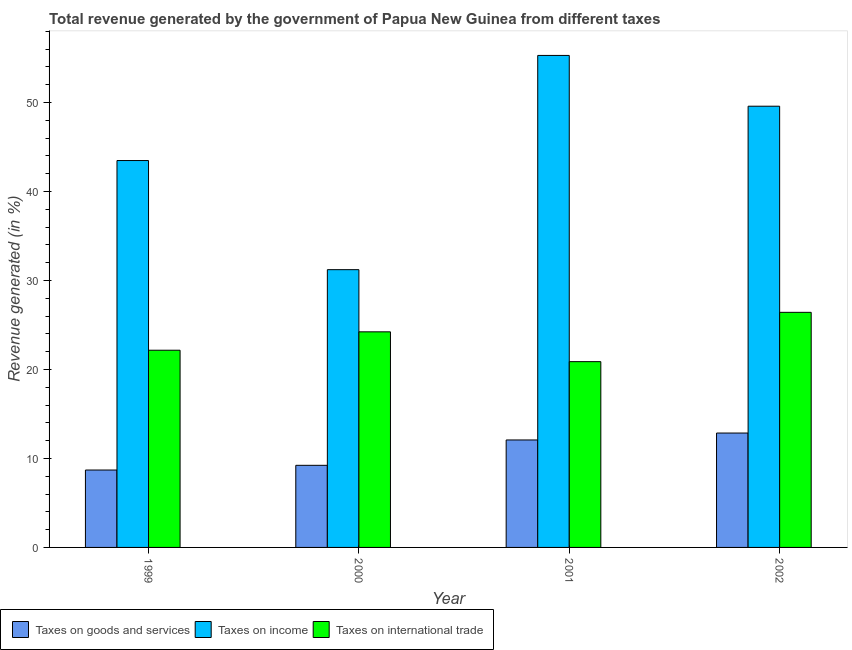Are the number of bars per tick equal to the number of legend labels?
Your answer should be compact. Yes. Are the number of bars on each tick of the X-axis equal?
Ensure brevity in your answer.  Yes. How many bars are there on the 4th tick from the left?
Your answer should be compact. 3. How many bars are there on the 1st tick from the right?
Provide a short and direct response. 3. What is the label of the 2nd group of bars from the left?
Offer a terse response. 2000. What is the percentage of revenue generated by taxes on goods and services in 2001?
Keep it short and to the point. 12.08. Across all years, what is the maximum percentage of revenue generated by taxes on goods and services?
Your answer should be compact. 12.86. Across all years, what is the minimum percentage of revenue generated by taxes on goods and services?
Offer a very short reply. 8.7. In which year was the percentage of revenue generated by tax on international trade maximum?
Your response must be concise. 2002. What is the total percentage of revenue generated by tax on international trade in the graph?
Offer a terse response. 93.7. What is the difference between the percentage of revenue generated by taxes on goods and services in 2001 and that in 2002?
Keep it short and to the point. -0.78. What is the difference between the percentage of revenue generated by taxes on goods and services in 1999 and the percentage of revenue generated by taxes on income in 2001?
Offer a terse response. -3.38. What is the average percentage of revenue generated by taxes on income per year?
Offer a very short reply. 44.9. What is the ratio of the percentage of revenue generated by tax on international trade in 1999 to that in 2000?
Your answer should be very brief. 0.91. Is the difference between the percentage of revenue generated by tax on international trade in 2000 and 2002 greater than the difference between the percentage of revenue generated by taxes on goods and services in 2000 and 2002?
Offer a very short reply. No. What is the difference between the highest and the second highest percentage of revenue generated by taxes on income?
Provide a succinct answer. 5.71. What is the difference between the highest and the lowest percentage of revenue generated by tax on international trade?
Your answer should be compact. 5.54. What does the 2nd bar from the left in 2002 represents?
Ensure brevity in your answer.  Taxes on income. What does the 1st bar from the right in 2002 represents?
Keep it short and to the point. Taxes on international trade. Is it the case that in every year, the sum of the percentage of revenue generated by taxes on goods and services and percentage of revenue generated by taxes on income is greater than the percentage of revenue generated by tax on international trade?
Offer a very short reply. Yes. Are the values on the major ticks of Y-axis written in scientific E-notation?
Offer a very short reply. No. Where does the legend appear in the graph?
Provide a short and direct response. Bottom left. What is the title of the graph?
Give a very brief answer. Total revenue generated by the government of Papua New Guinea from different taxes. What is the label or title of the X-axis?
Provide a short and direct response. Year. What is the label or title of the Y-axis?
Give a very brief answer. Revenue generated (in %). What is the Revenue generated (in %) in Taxes on goods and services in 1999?
Your response must be concise. 8.7. What is the Revenue generated (in %) in Taxes on income in 1999?
Your answer should be very brief. 43.48. What is the Revenue generated (in %) in Taxes on international trade in 1999?
Provide a short and direct response. 22.16. What is the Revenue generated (in %) in Taxes on goods and services in 2000?
Your answer should be compact. 9.23. What is the Revenue generated (in %) in Taxes on income in 2000?
Give a very brief answer. 31.22. What is the Revenue generated (in %) of Taxes on international trade in 2000?
Keep it short and to the point. 24.23. What is the Revenue generated (in %) in Taxes on goods and services in 2001?
Make the answer very short. 12.08. What is the Revenue generated (in %) in Taxes on income in 2001?
Provide a succinct answer. 55.3. What is the Revenue generated (in %) in Taxes on international trade in 2001?
Provide a succinct answer. 20.88. What is the Revenue generated (in %) of Taxes on goods and services in 2002?
Offer a very short reply. 12.86. What is the Revenue generated (in %) of Taxes on income in 2002?
Your answer should be compact. 49.59. What is the Revenue generated (in %) of Taxes on international trade in 2002?
Ensure brevity in your answer.  26.42. Across all years, what is the maximum Revenue generated (in %) in Taxes on goods and services?
Provide a short and direct response. 12.86. Across all years, what is the maximum Revenue generated (in %) in Taxes on income?
Your response must be concise. 55.3. Across all years, what is the maximum Revenue generated (in %) in Taxes on international trade?
Keep it short and to the point. 26.42. Across all years, what is the minimum Revenue generated (in %) in Taxes on goods and services?
Offer a very short reply. 8.7. Across all years, what is the minimum Revenue generated (in %) in Taxes on income?
Provide a short and direct response. 31.22. Across all years, what is the minimum Revenue generated (in %) in Taxes on international trade?
Provide a short and direct response. 20.88. What is the total Revenue generated (in %) of Taxes on goods and services in the graph?
Provide a succinct answer. 42.86. What is the total Revenue generated (in %) in Taxes on income in the graph?
Offer a terse response. 179.59. What is the total Revenue generated (in %) in Taxes on international trade in the graph?
Give a very brief answer. 93.7. What is the difference between the Revenue generated (in %) in Taxes on goods and services in 1999 and that in 2000?
Your answer should be very brief. -0.53. What is the difference between the Revenue generated (in %) of Taxes on income in 1999 and that in 2000?
Provide a succinct answer. 12.27. What is the difference between the Revenue generated (in %) in Taxes on international trade in 1999 and that in 2000?
Your response must be concise. -2.07. What is the difference between the Revenue generated (in %) of Taxes on goods and services in 1999 and that in 2001?
Make the answer very short. -3.38. What is the difference between the Revenue generated (in %) of Taxes on income in 1999 and that in 2001?
Give a very brief answer. -11.81. What is the difference between the Revenue generated (in %) in Taxes on international trade in 1999 and that in 2001?
Provide a succinct answer. 1.28. What is the difference between the Revenue generated (in %) of Taxes on goods and services in 1999 and that in 2002?
Make the answer very short. -4.16. What is the difference between the Revenue generated (in %) in Taxes on income in 1999 and that in 2002?
Your response must be concise. -6.11. What is the difference between the Revenue generated (in %) in Taxes on international trade in 1999 and that in 2002?
Your answer should be very brief. -4.26. What is the difference between the Revenue generated (in %) in Taxes on goods and services in 2000 and that in 2001?
Offer a terse response. -2.85. What is the difference between the Revenue generated (in %) of Taxes on income in 2000 and that in 2001?
Your response must be concise. -24.08. What is the difference between the Revenue generated (in %) in Taxes on international trade in 2000 and that in 2001?
Give a very brief answer. 3.35. What is the difference between the Revenue generated (in %) in Taxes on goods and services in 2000 and that in 2002?
Provide a short and direct response. -3.63. What is the difference between the Revenue generated (in %) of Taxes on income in 2000 and that in 2002?
Your answer should be very brief. -18.37. What is the difference between the Revenue generated (in %) in Taxes on international trade in 2000 and that in 2002?
Offer a terse response. -2.19. What is the difference between the Revenue generated (in %) in Taxes on goods and services in 2001 and that in 2002?
Ensure brevity in your answer.  -0.78. What is the difference between the Revenue generated (in %) in Taxes on income in 2001 and that in 2002?
Make the answer very short. 5.71. What is the difference between the Revenue generated (in %) in Taxes on international trade in 2001 and that in 2002?
Give a very brief answer. -5.54. What is the difference between the Revenue generated (in %) in Taxes on goods and services in 1999 and the Revenue generated (in %) in Taxes on income in 2000?
Provide a succinct answer. -22.52. What is the difference between the Revenue generated (in %) of Taxes on goods and services in 1999 and the Revenue generated (in %) of Taxes on international trade in 2000?
Your response must be concise. -15.53. What is the difference between the Revenue generated (in %) in Taxes on income in 1999 and the Revenue generated (in %) in Taxes on international trade in 2000?
Provide a short and direct response. 19.25. What is the difference between the Revenue generated (in %) of Taxes on goods and services in 1999 and the Revenue generated (in %) of Taxes on income in 2001?
Ensure brevity in your answer.  -46.6. What is the difference between the Revenue generated (in %) of Taxes on goods and services in 1999 and the Revenue generated (in %) of Taxes on international trade in 2001?
Make the answer very short. -12.18. What is the difference between the Revenue generated (in %) of Taxes on income in 1999 and the Revenue generated (in %) of Taxes on international trade in 2001?
Keep it short and to the point. 22.6. What is the difference between the Revenue generated (in %) in Taxes on goods and services in 1999 and the Revenue generated (in %) in Taxes on income in 2002?
Keep it short and to the point. -40.89. What is the difference between the Revenue generated (in %) of Taxes on goods and services in 1999 and the Revenue generated (in %) of Taxes on international trade in 2002?
Your answer should be compact. -17.72. What is the difference between the Revenue generated (in %) of Taxes on income in 1999 and the Revenue generated (in %) of Taxes on international trade in 2002?
Your answer should be compact. 17.06. What is the difference between the Revenue generated (in %) in Taxes on goods and services in 2000 and the Revenue generated (in %) in Taxes on income in 2001?
Offer a very short reply. -46.07. What is the difference between the Revenue generated (in %) in Taxes on goods and services in 2000 and the Revenue generated (in %) in Taxes on international trade in 2001?
Give a very brief answer. -11.65. What is the difference between the Revenue generated (in %) of Taxes on income in 2000 and the Revenue generated (in %) of Taxes on international trade in 2001?
Provide a succinct answer. 10.34. What is the difference between the Revenue generated (in %) in Taxes on goods and services in 2000 and the Revenue generated (in %) in Taxes on income in 2002?
Your answer should be very brief. -40.36. What is the difference between the Revenue generated (in %) in Taxes on goods and services in 2000 and the Revenue generated (in %) in Taxes on international trade in 2002?
Give a very brief answer. -17.19. What is the difference between the Revenue generated (in %) of Taxes on income in 2000 and the Revenue generated (in %) of Taxes on international trade in 2002?
Keep it short and to the point. 4.79. What is the difference between the Revenue generated (in %) of Taxes on goods and services in 2001 and the Revenue generated (in %) of Taxes on income in 2002?
Your response must be concise. -37.51. What is the difference between the Revenue generated (in %) in Taxes on goods and services in 2001 and the Revenue generated (in %) in Taxes on international trade in 2002?
Ensure brevity in your answer.  -14.35. What is the difference between the Revenue generated (in %) in Taxes on income in 2001 and the Revenue generated (in %) in Taxes on international trade in 2002?
Make the answer very short. 28.87. What is the average Revenue generated (in %) of Taxes on goods and services per year?
Your answer should be very brief. 10.72. What is the average Revenue generated (in %) of Taxes on income per year?
Ensure brevity in your answer.  44.9. What is the average Revenue generated (in %) in Taxes on international trade per year?
Your response must be concise. 23.42. In the year 1999, what is the difference between the Revenue generated (in %) of Taxes on goods and services and Revenue generated (in %) of Taxes on income?
Your answer should be compact. -34.78. In the year 1999, what is the difference between the Revenue generated (in %) of Taxes on goods and services and Revenue generated (in %) of Taxes on international trade?
Ensure brevity in your answer.  -13.46. In the year 1999, what is the difference between the Revenue generated (in %) of Taxes on income and Revenue generated (in %) of Taxes on international trade?
Offer a terse response. 21.32. In the year 2000, what is the difference between the Revenue generated (in %) in Taxes on goods and services and Revenue generated (in %) in Taxes on income?
Provide a succinct answer. -21.99. In the year 2000, what is the difference between the Revenue generated (in %) in Taxes on goods and services and Revenue generated (in %) in Taxes on international trade?
Your answer should be very brief. -15. In the year 2000, what is the difference between the Revenue generated (in %) of Taxes on income and Revenue generated (in %) of Taxes on international trade?
Keep it short and to the point. 6.99. In the year 2001, what is the difference between the Revenue generated (in %) of Taxes on goods and services and Revenue generated (in %) of Taxes on income?
Keep it short and to the point. -43.22. In the year 2001, what is the difference between the Revenue generated (in %) in Taxes on goods and services and Revenue generated (in %) in Taxes on international trade?
Offer a terse response. -8.8. In the year 2001, what is the difference between the Revenue generated (in %) of Taxes on income and Revenue generated (in %) of Taxes on international trade?
Provide a short and direct response. 34.42. In the year 2002, what is the difference between the Revenue generated (in %) in Taxes on goods and services and Revenue generated (in %) in Taxes on income?
Make the answer very short. -36.73. In the year 2002, what is the difference between the Revenue generated (in %) of Taxes on goods and services and Revenue generated (in %) of Taxes on international trade?
Your answer should be very brief. -13.57. In the year 2002, what is the difference between the Revenue generated (in %) of Taxes on income and Revenue generated (in %) of Taxes on international trade?
Give a very brief answer. 23.17. What is the ratio of the Revenue generated (in %) in Taxes on goods and services in 1999 to that in 2000?
Offer a very short reply. 0.94. What is the ratio of the Revenue generated (in %) in Taxes on income in 1999 to that in 2000?
Keep it short and to the point. 1.39. What is the ratio of the Revenue generated (in %) of Taxes on international trade in 1999 to that in 2000?
Make the answer very short. 0.91. What is the ratio of the Revenue generated (in %) in Taxes on goods and services in 1999 to that in 2001?
Give a very brief answer. 0.72. What is the ratio of the Revenue generated (in %) of Taxes on income in 1999 to that in 2001?
Offer a very short reply. 0.79. What is the ratio of the Revenue generated (in %) in Taxes on international trade in 1999 to that in 2001?
Offer a terse response. 1.06. What is the ratio of the Revenue generated (in %) in Taxes on goods and services in 1999 to that in 2002?
Offer a very short reply. 0.68. What is the ratio of the Revenue generated (in %) of Taxes on income in 1999 to that in 2002?
Your response must be concise. 0.88. What is the ratio of the Revenue generated (in %) of Taxes on international trade in 1999 to that in 2002?
Your answer should be compact. 0.84. What is the ratio of the Revenue generated (in %) in Taxes on goods and services in 2000 to that in 2001?
Your answer should be very brief. 0.76. What is the ratio of the Revenue generated (in %) in Taxes on income in 2000 to that in 2001?
Your answer should be compact. 0.56. What is the ratio of the Revenue generated (in %) in Taxes on international trade in 2000 to that in 2001?
Your response must be concise. 1.16. What is the ratio of the Revenue generated (in %) in Taxes on goods and services in 2000 to that in 2002?
Offer a terse response. 0.72. What is the ratio of the Revenue generated (in %) in Taxes on income in 2000 to that in 2002?
Give a very brief answer. 0.63. What is the ratio of the Revenue generated (in %) of Taxes on international trade in 2000 to that in 2002?
Offer a very short reply. 0.92. What is the ratio of the Revenue generated (in %) of Taxes on goods and services in 2001 to that in 2002?
Provide a succinct answer. 0.94. What is the ratio of the Revenue generated (in %) in Taxes on income in 2001 to that in 2002?
Give a very brief answer. 1.12. What is the ratio of the Revenue generated (in %) in Taxes on international trade in 2001 to that in 2002?
Ensure brevity in your answer.  0.79. What is the difference between the highest and the second highest Revenue generated (in %) in Taxes on goods and services?
Provide a succinct answer. 0.78. What is the difference between the highest and the second highest Revenue generated (in %) of Taxes on income?
Offer a very short reply. 5.71. What is the difference between the highest and the second highest Revenue generated (in %) in Taxes on international trade?
Offer a very short reply. 2.19. What is the difference between the highest and the lowest Revenue generated (in %) in Taxes on goods and services?
Keep it short and to the point. 4.16. What is the difference between the highest and the lowest Revenue generated (in %) in Taxes on income?
Keep it short and to the point. 24.08. What is the difference between the highest and the lowest Revenue generated (in %) in Taxes on international trade?
Ensure brevity in your answer.  5.54. 